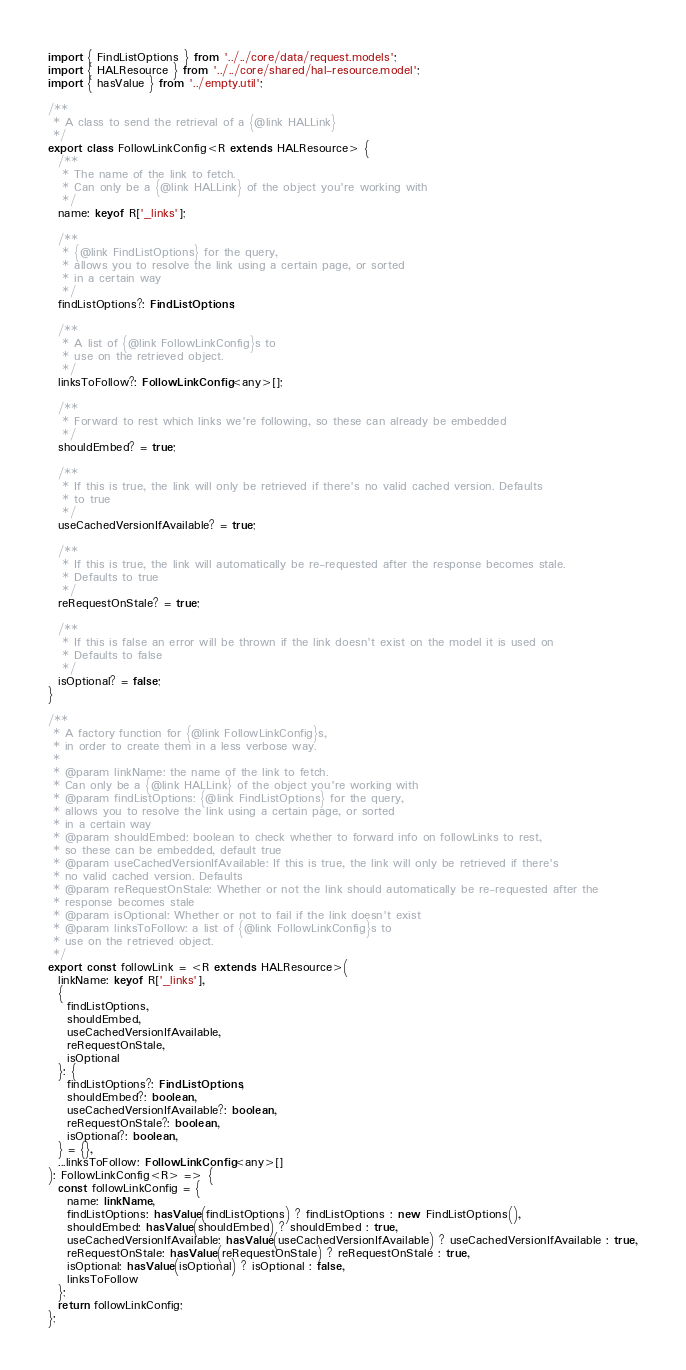<code> <loc_0><loc_0><loc_500><loc_500><_TypeScript_>import { FindListOptions } from '../../core/data/request.models';
import { HALResource } from '../../core/shared/hal-resource.model';
import { hasValue } from '../empty.util';

/**
 * A class to send the retrieval of a {@link HALLink}
 */
export class FollowLinkConfig<R extends HALResource> {
  /**
   * The name of the link to fetch.
   * Can only be a {@link HALLink} of the object you're working with
   */
  name: keyof R['_links'];

  /**
   * {@link FindListOptions} for the query,
   * allows you to resolve the link using a certain page, or sorted
   * in a certain way
   */
  findListOptions?: FindListOptions;

  /**
   * A list of {@link FollowLinkConfig}s to
   * use on the retrieved object.
   */
  linksToFollow?: FollowLinkConfig<any>[];

  /**
   * Forward to rest which links we're following, so these can already be embedded
   */
  shouldEmbed? = true;

  /**
   * If this is true, the link will only be retrieved if there's no valid cached version. Defaults
   * to true
   */
  useCachedVersionIfAvailable? = true;

  /**
   * If this is true, the link will automatically be re-requested after the response becomes stale.
   * Defaults to true
   */
  reRequestOnStale? = true;

  /**
   * If this is false an error will be thrown if the link doesn't exist on the model it is used on
   * Defaults to false
   */
  isOptional? = false;
}

/**
 * A factory function for {@link FollowLinkConfig}s,
 * in order to create them in a less verbose way.
 *
 * @param linkName: the name of the link to fetch.
 * Can only be a {@link HALLink} of the object you're working with
 * @param findListOptions: {@link FindListOptions} for the query,
 * allows you to resolve the link using a certain page, or sorted
 * in a certain way
 * @param shouldEmbed: boolean to check whether to forward info on followLinks to rest,
 * so these can be embedded, default true
 * @param useCachedVersionIfAvailable: If this is true, the link will only be retrieved if there's
 * no valid cached version. Defaults
 * @param reRequestOnStale: Whether or not the link should automatically be re-requested after the
 * response becomes stale
 * @param isOptional: Whether or not to fail if the link doesn't exist
 * @param linksToFollow: a list of {@link FollowLinkConfig}s to
 * use on the retrieved object.
 */
export const followLink = <R extends HALResource>(
  linkName: keyof R['_links'],
  {
    findListOptions,
    shouldEmbed,
    useCachedVersionIfAvailable,
    reRequestOnStale,
    isOptional
  }: {
    findListOptions?: FindListOptions,
    shouldEmbed?: boolean,
    useCachedVersionIfAvailable?: boolean,
    reRequestOnStale?: boolean,
    isOptional?: boolean,
  } = {},
  ...linksToFollow: FollowLinkConfig<any>[]
): FollowLinkConfig<R> => {
  const followLinkConfig = {
    name: linkName,
    findListOptions: hasValue(findListOptions) ? findListOptions : new FindListOptions(),
    shouldEmbed: hasValue(shouldEmbed) ? shouldEmbed : true,
    useCachedVersionIfAvailable: hasValue(useCachedVersionIfAvailable) ? useCachedVersionIfAvailable : true,
    reRequestOnStale: hasValue(reRequestOnStale) ? reRequestOnStale : true,
    isOptional: hasValue(isOptional) ? isOptional : false,
    linksToFollow
  };
  return followLinkConfig;
};
</code> 